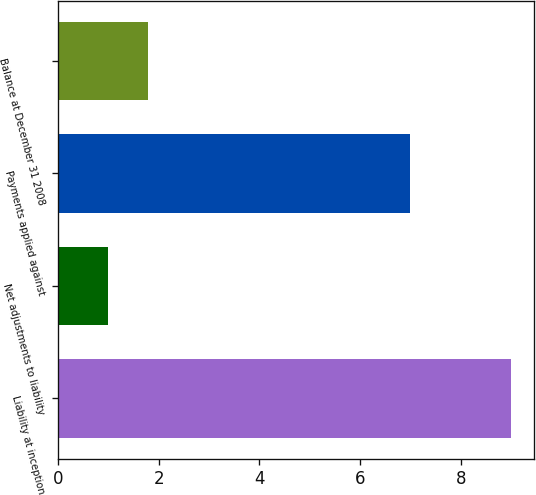Convert chart. <chart><loc_0><loc_0><loc_500><loc_500><bar_chart><fcel>Liability at inception<fcel>Net adjustments to liability<fcel>Payments applied against<fcel>Balance at December 31 2008<nl><fcel>9<fcel>1<fcel>7<fcel>1.8<nl></chart> 